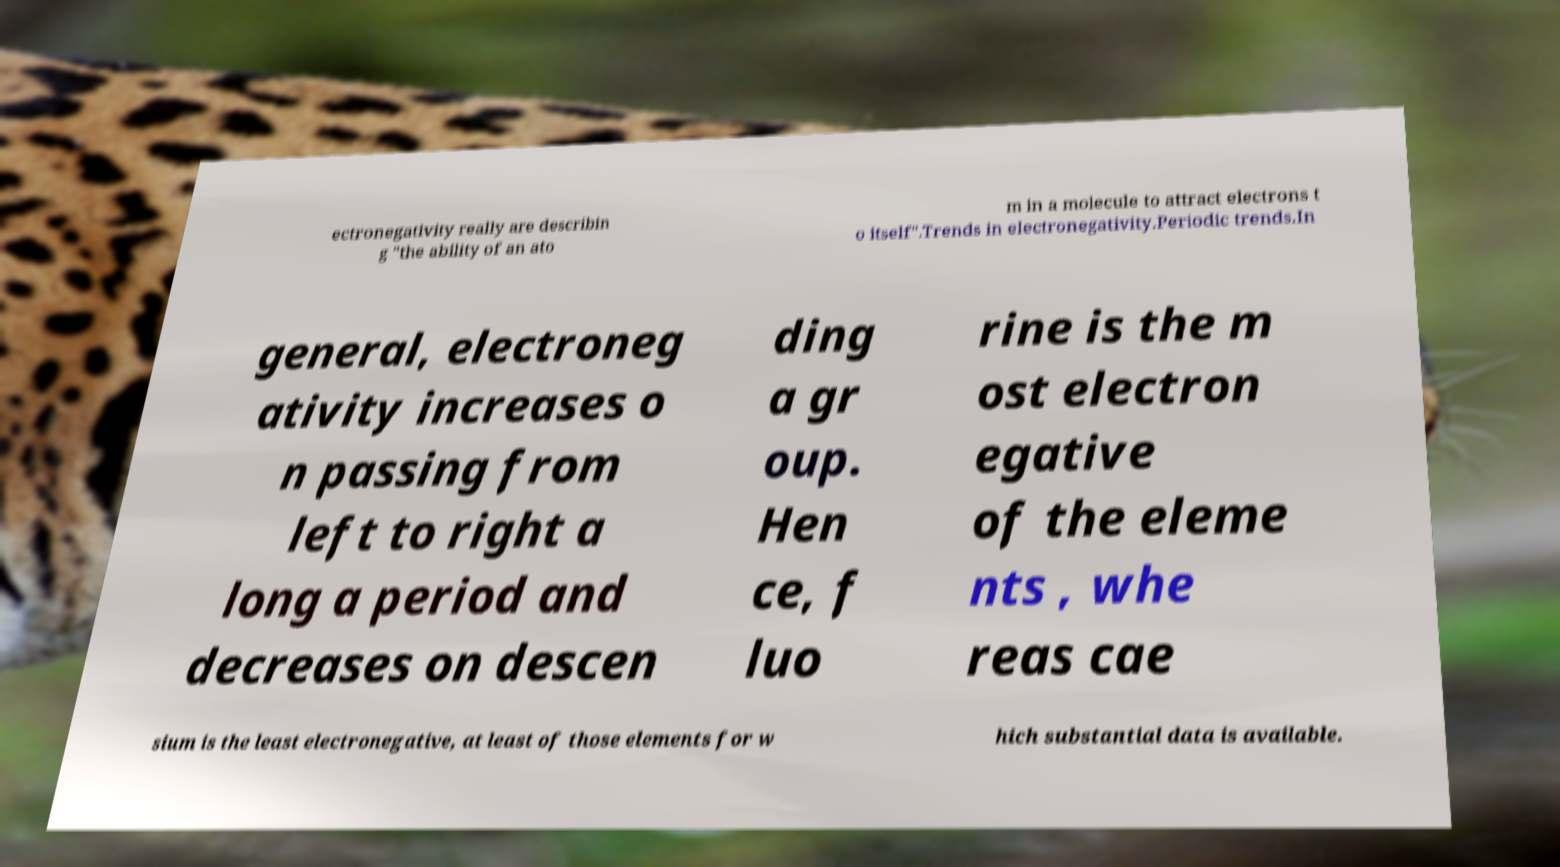There's text embedded in this image that I need extracted. Can you transcribe it verbatim? ectronegativity really are describin g "the ability of an ato m in a molecule to attract electrons t o itself".Trends in electronegativity.Periodic trends.In general, electroneg ativity increases o n passing from left to right a long a period and decreases on descen ding a gr oup. Hen ce, f luo rine is the m ost electron egative of the eleme nts , whe reas cae sium is the least electronegative, at least of those elements for w hich substantial data is available. 